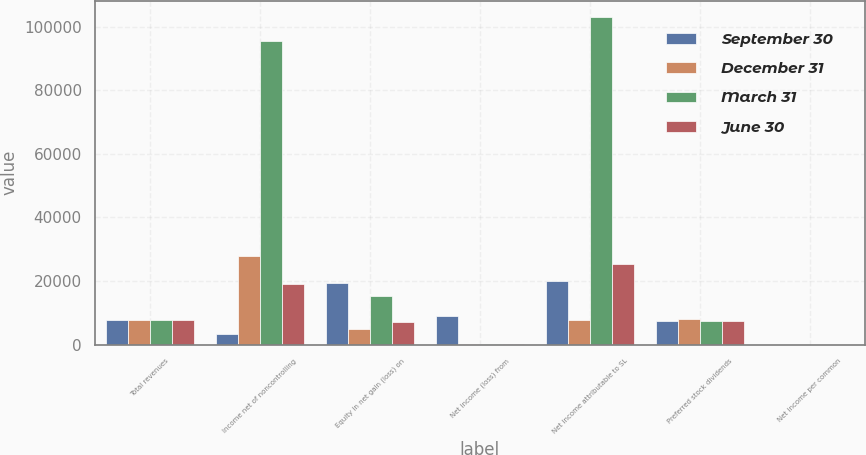Convert chart to OTSL. <chart><loc_0><loc_0><loc_500><loc_500><stacked_bar_chart><ecel><fcel>Total revenues<fcel>Income net of noncontrolling<fcel>Equity in net gain (loss) on<fcel>Net income (loss) from<fcel>Net income attributable to SL<fcel>Preferred stock dividends<fcel>Net income per common<nl><fcel>September 30<fcel>7823.5<fcel>3235<fcel>19277<fcel>9126<fcel>19956<fcel>7407<fcel>0.23<nl><fcel>December 31<fcel>7823.5<fcel>28010<fcel>4807<fcel>217<fcel>7732<fcel>7915<fcel>0.09<nl><fcel>March 31<fcel>7823.5<fcel>95328<fcel>15323<fcel>67<fcel>103040<fcel>7544<fcel>1.15<nl><fcel>June 30<fcel>7823.5<fcel>19074<fcel>7260<fcel>160<fcel>25256<fcel>7545<fcel>0.29<nl></chart> 